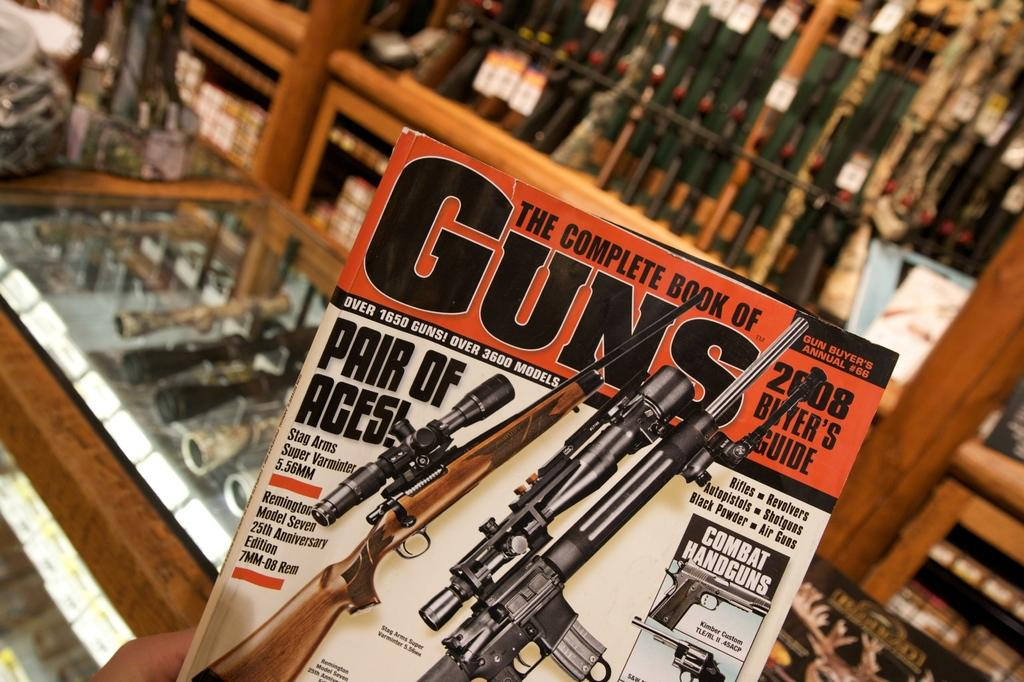<image>
Write a terse but informative summary of the picture. A magazine called GUNS with rifles on the cover. 